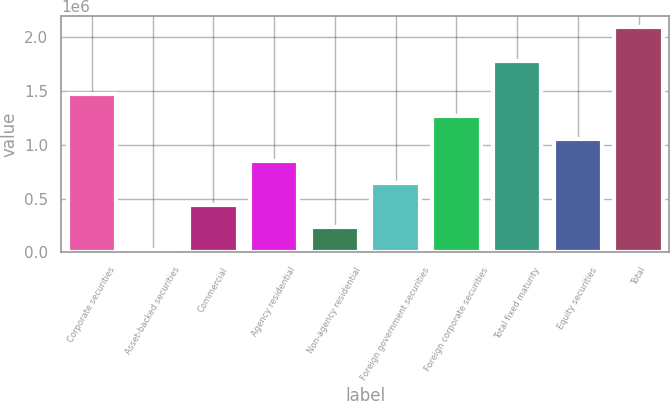Convert chart to OTSL. <chart><loc_0><loc_0><loc_500><loc_500><bar_chart><fcel>Corporate securities<fcel>Asset-backed securities<fcel>Commercial<fcel>Agency residential<fcel>Non-agency residential<fcel>Foreign government securities<fcel>Foreign corporate securities<fcel>Total fixed maturity<fcel>Equity securities<fcel>Total<nl><fcel>1.47063e+06<fcel>24494<fcel>437676<fcel>850857<fcel>231085<fcel>644266<fcel>1.26404e+06<fcel>1.777e+06<fcel>1.05745e+06<fcel>2.0904e+06<nl></chart> 